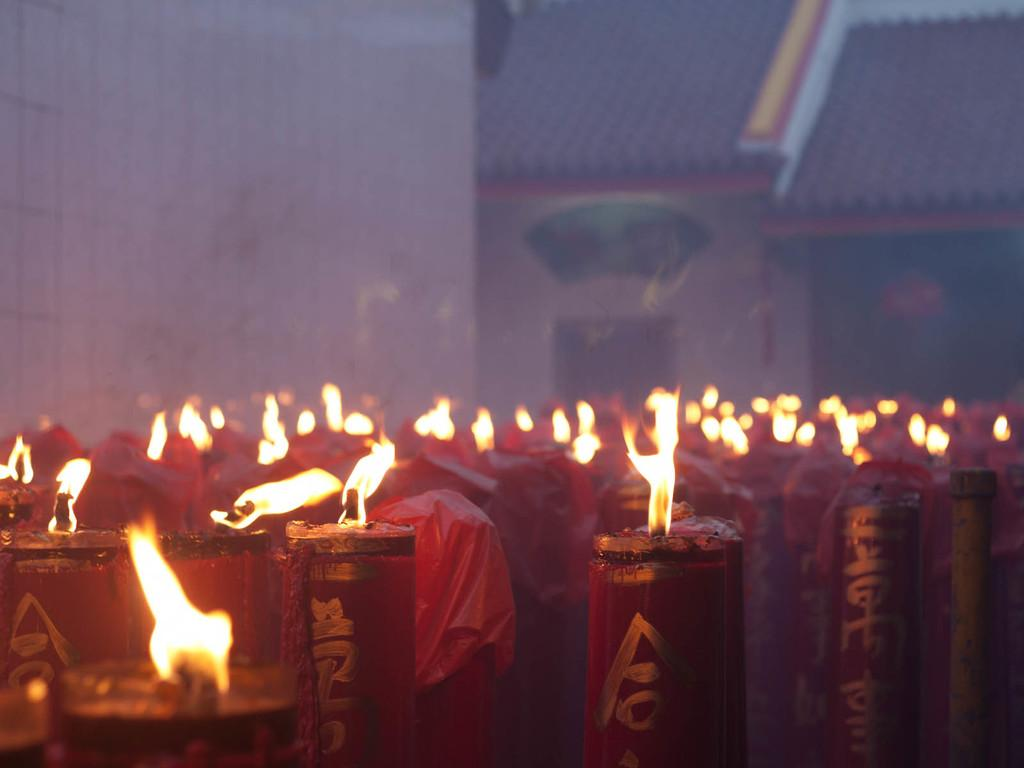What is the main subject of the image? The main subject of the image is a group of candles. How are the candles in the image? The candles are light up with fire. What can be seen in the background of the image? There is a building in the background of the image. How many centimeters does the curve of the war take up in the image? There is no curve or war present in the image; it features a group of candles light up with fire and a building in the background. 